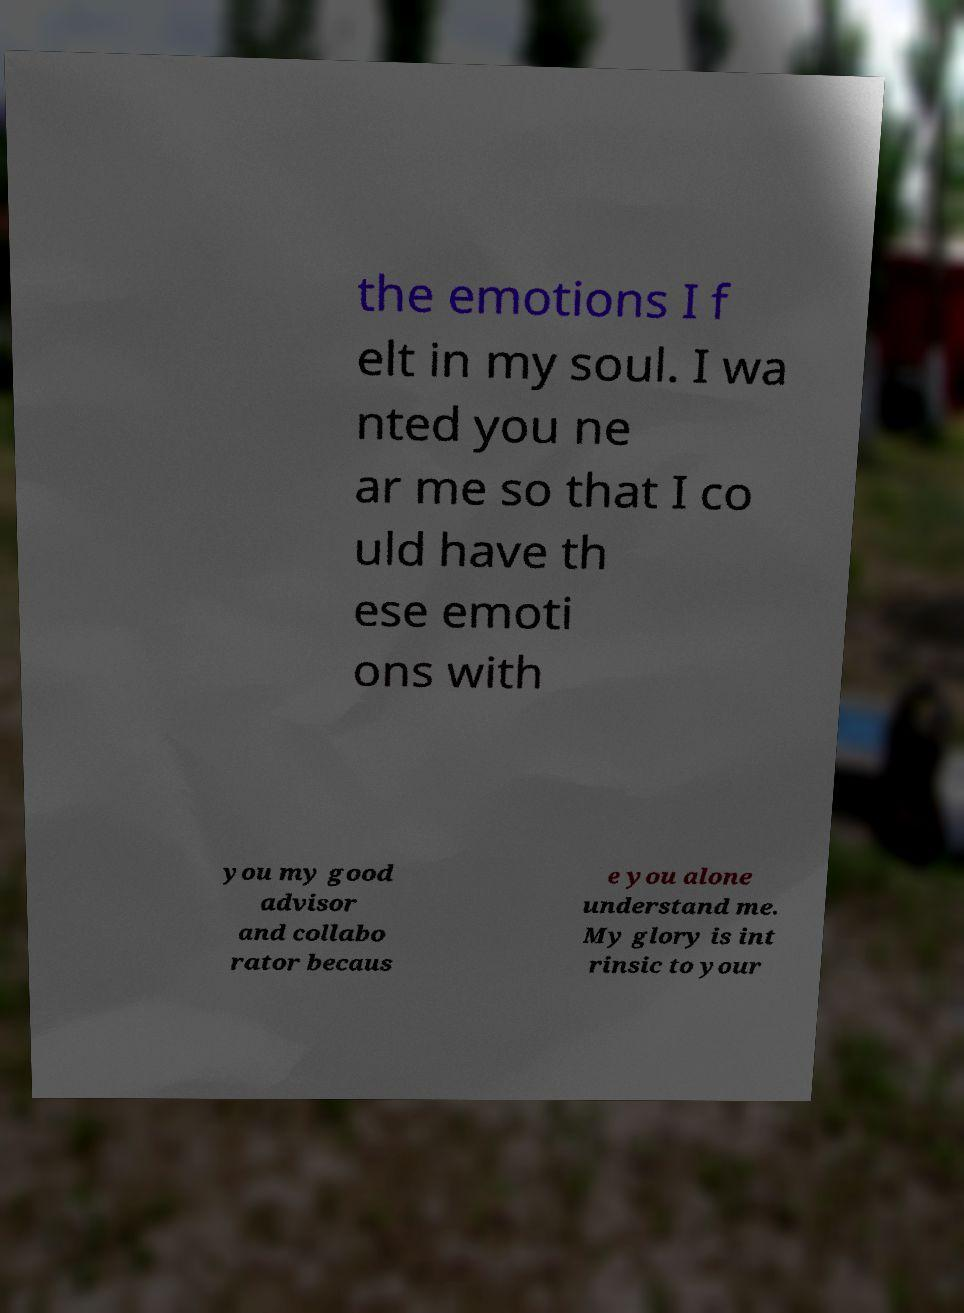Can you accurately transcribe the text from the provided image for me? the emotions I f elt in my soul. I wa nted you ne ar me so that I co uld have th ese emoti ons with you my good advisor and collabo rator becaus e you alone understand me. My glory is int rinsic to your 